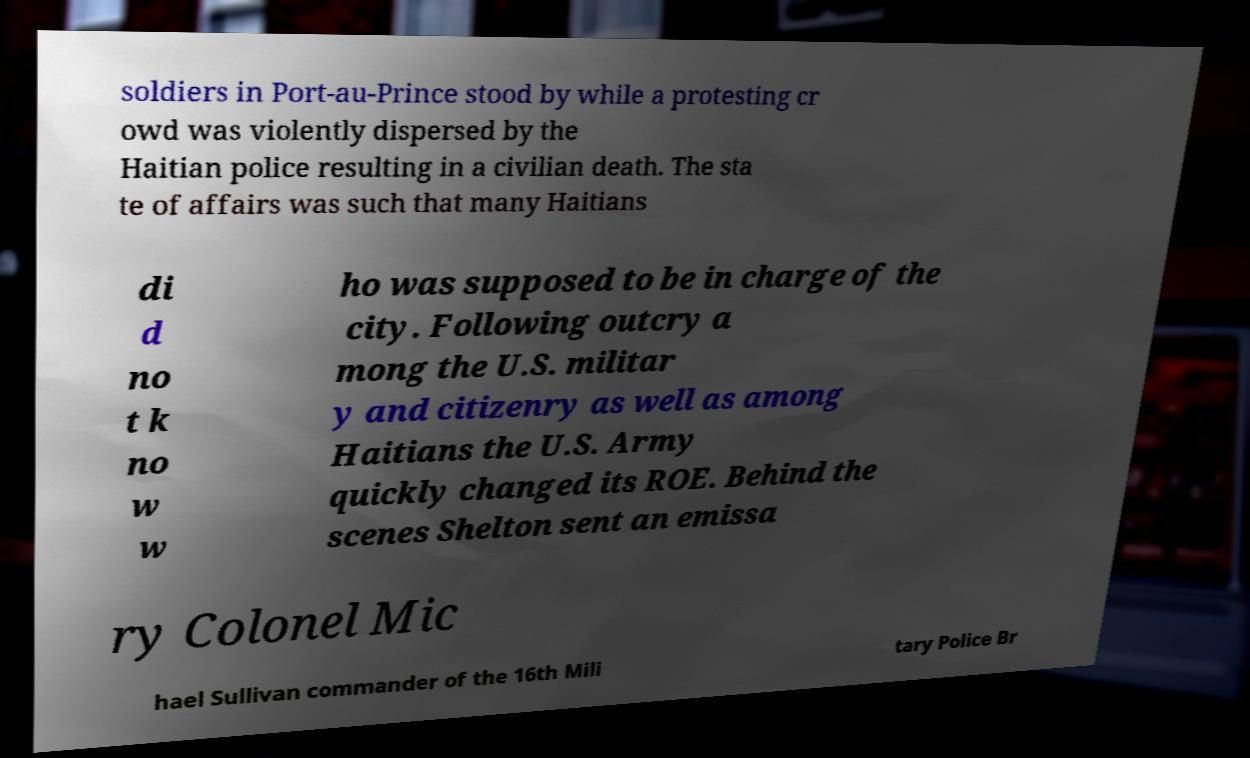For documentation purposes, I need the text within this image transcribed. Could you provide that? soldiers in Port-au-Prince stood by while a protesting cr owd was violently dispersed by the Haitian police resulting in a civilian death. The sta te of affairs was such that many Haitians di d no t k no w w ho was supposed to be in charge of the city. Following outcry a mong the U.S. militar y and citizenry as well as among Haitians the U.S. Army quickly changed its ROE. Behind the scenes Shelton sent an emissa ry Colonel Mic hael Sullivan commander of the 16th Mili tary Police Br 